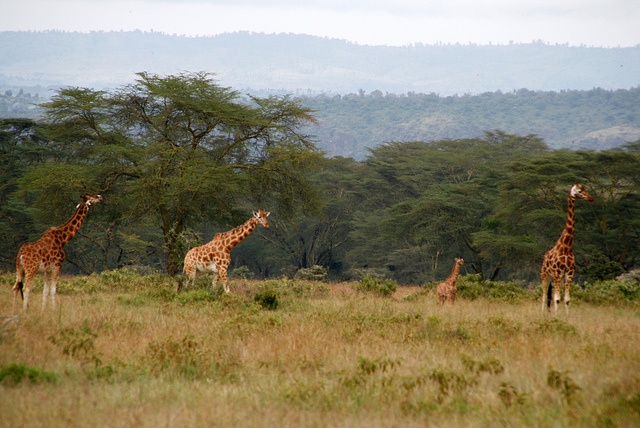Describe the objects in this image and their specific colors. I can see giraffe in lightgray, maroon, brown, and black tones, giraffe in lightgray, maroon, brown, and black tones, and giraffe in lightgray, brown, tan, and gray tones in this image. 